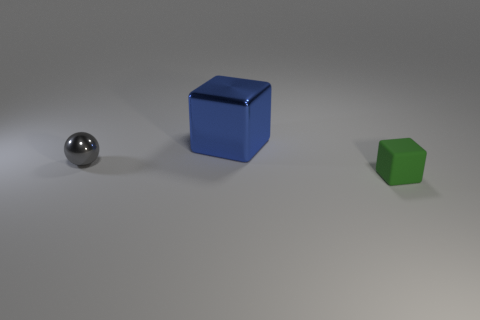Add 3 metallic spheres. How many objects exist? 6 Subtract all cubes. How many objects are left? 1 Add 1 tiny gray shiny objects. How many tiny gray shiny objects exist? 2 Subtract 0 blue spheres. How many objects are left? 3 Subtract all cyan metal cylinders. Subtract all blue shiny blocks. How many objects are left? 2 Add 1 metal blocks. How many metal blocks are left? 2 